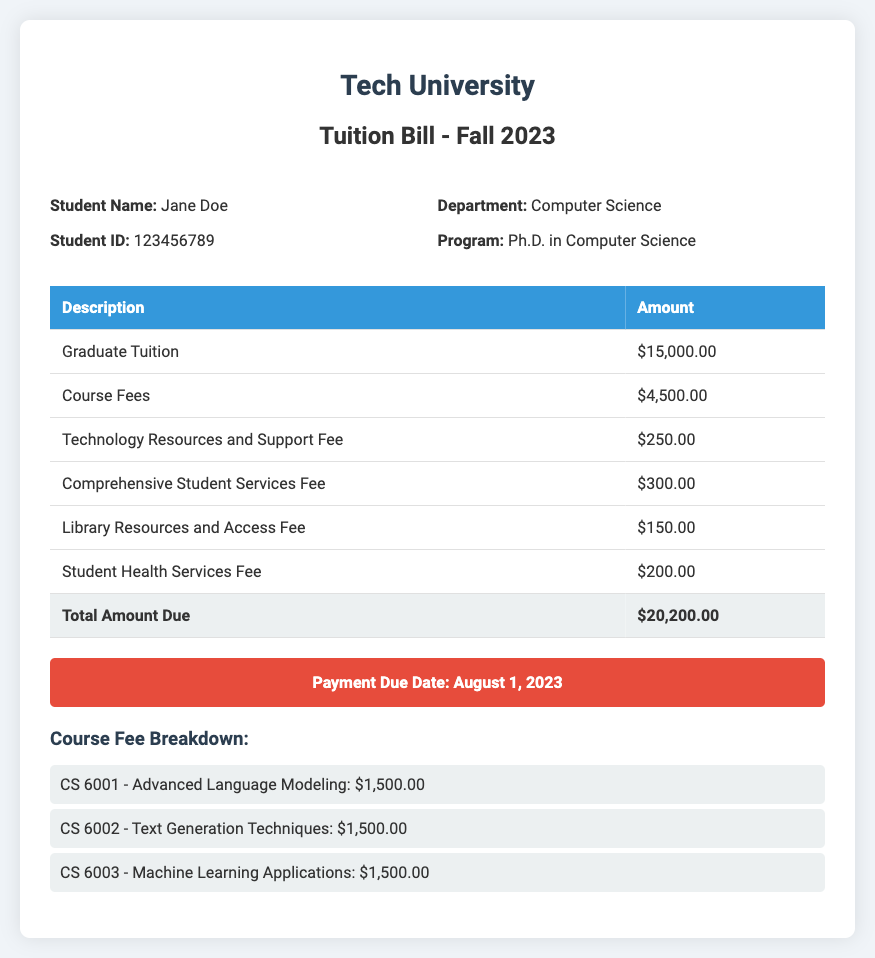What is the total amount due? The total amount due is listed in the document as the sum of all charges, which is $20,200.00.
Answer: $20,200.00 What is the payment due date? The payment due date is specifically mentioned at the bottom of the document as August 1, 2023.
Answer: August 1, 2023 How much is the Graduate Tuition? The Graduate Tuition is detailed as $15,000.00 in the fees table.
Answer: $15,000.00 What is the amount for the Student Health Services Fee? The Student Health Services Fee is noted separately in the document, stated as $200.00.
Answer: $200.00 Which course has a fee of $1,500.00? The courses listed include several with the same fee, specifically CS 6001, CS 6002, and CS 6003 all have that amount.
Answer: CS 6001, CS 6002, CS 6003 How much is charged for the Comprehensive Student Services Fee? The Comprehensive Student Services Fee is shown in the table as $300.00.
Answer: $300.00 What is the Department of the student? The student’s department is listed clearly under the student information section as Computer Science.
Answer: Computer Science How many courses are included in the Course Fee Breakdown? The Course Fee Breakdown lists a total of three courses, each with a fee.
Answer: Three 